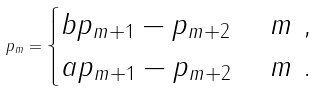Convert formula to latex. <formula><loc_0><loc_0><loc_500><loc_500>p _ { m } = \begin{cases} b p _ { m + 1 } - p _ { m + 2 } & \ m \ , \\ a p _ { m + 1 } - p _ { m + 2 } & \ m \ . \\ \end{cases}</formula> 